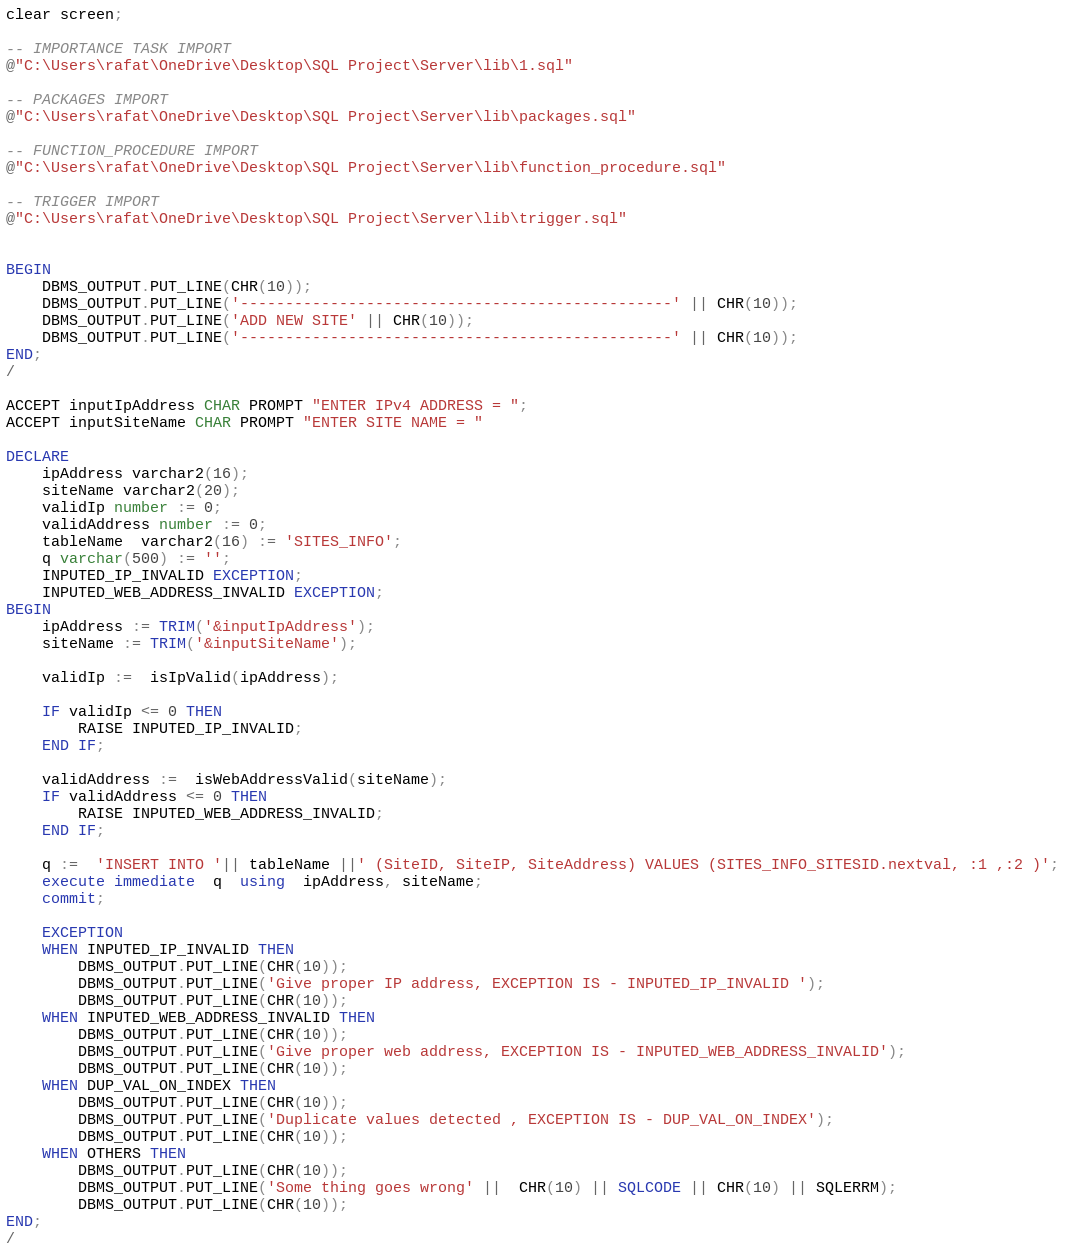<code> <loc_0><loc_0><loc_500><loc_500><_SQL_>clear screen;

-- IMPORTANCE TASK IMPORT
@"C:\Users\rafat\OneDrive\Desktop\SQL Project\Server\lib\1.sql" 

-- PACKAGES IMPORT
@"C:\Users\rafat\OneDrive\Desktop\SQL Project\Server\lib\packages.sql"

-- FUNCTION_PROCEDURE IMPORT
@"C:\Users\rafat\OneDrive\Desktop\SQL Project\Server\lib\function_procedure.sql"

-- TRIGGER IMPORT
@"C:\Users\rafat\OneDrive\Desktop\SQL Project\Server\lib\trigger.sql"


BEGIN
    DBMS_OUTPUT.PUT_LINE(CHR(10));
	DBMS_OUTPUT.PUT_LINE('------------------------------------------------' || CHR(10));
    DBMS_OUTPUT.PUT_LINE('ADD NEW SITE' || CHR(10));
    DBMS_OUTPUT.PUT_LINE('------------------------------------------------' || CHR(10));
END;
/

ACCEPT inputIpAddress CHAR PROMPT "ENTER IPv4 ADDRESS = ";
ACCEPT inputSiteName CHAR PROMPT "ENTER SITE NAME = "

DECLARE
	ipAddress varchar2(16);
	siteName varchar2(20);
    validIp number := 0;
    validAddress number := 0;
    tableName  varchar2(16) := 'SITES_INFO';
    q varchar(500) := '';
    INPUTED_IP_INVALID EXCEPTION;
    INPUTED_WEB_ADDRESS_INVALID EXCEPTION;
BEGIN
    ipAddress := TRIM('&inputIpAddress');
    siteName := TRIM('&inputSiteName');
    
    validIp :=  isIpValid(ipAddress);
    
    IF validIp <= 0 THEN
		RAISE INPUTED_IP_INVALID;
	END IF;
    
    validAddress :=  isWebAddressValid(siteName);
    IF validAddress <= 0 THEN
		RAISE INPUTED_WEB_ADDRESS_INVALID;
	END IF;
    
    q :=  'INSERT INTO '|| tableName ||' (SiteID, SiteIP, SiteAddress) VALUES (SITES_INFO_SITESID.nextval, :1 ,:2 )';
    execute immediate  q  using  ipAddress, siteName;
    commit;
    
    EXCEPTION
    WHEN INPUTED_IP_INVALID THEN
        DBMS_OUTPUT.PUT_LINE(CHR(10));
        DBMS_OUTPUT.PUT_LINE('Give proper IP address, EXCEPTION IS - INPUTED_IP_INVALID ');
        DBMS_OUTPUT.PUT_LINE(CHR(10));
    WHEN INPUTED_WEB_ADDRESS_INVALID THEN
        DBMS_OUTPUT.PUT_LINE(CHR(10));
        DBMS_OUTPUT.PUT_LINE('Give proper web address, EXCEPTION IS - INPUTED_WEB_ADDRESS_INVALID');
        DBMS_OUTPUT.PUT_LINE(CHR(10));
    WHEN DUP_VAL_ON_INDEX THEN
        DBMS_OUTPUT.PUT_LINE(CHR(10));
        DBMS_OUTPUT.PUT_LINE('Duplicate values detected , EXCEPTION IS - DUP_VAL_ON_INDEX');
        DBMS_OUTPUT.PUT_LINE(CHR(10));
    WHEN OTHERS THEN
        DBMS_OUTPUT.PUT_LINE(CHR(10));
		DBMS_OUTPUT.PUT_LINE('Some thing goes wrong' ||  CHR(10) || SQLCODE || CHR(10) || SQLERRM);
        DBMS_OUTPUT.PUT_LINE(CHR(10));
END;
/
</code> 